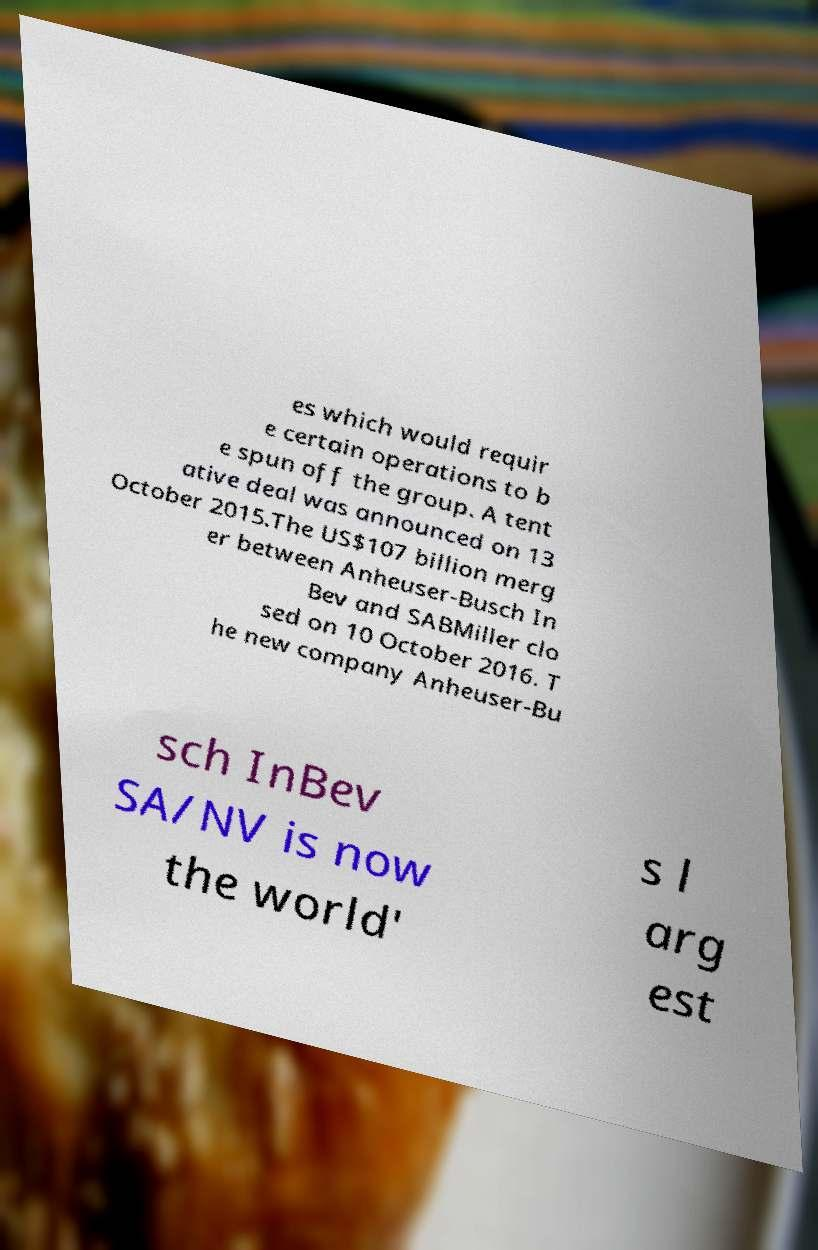For documentation purposes, I need the text within this image transcribed. Could you provide that? es which would requir e certain operations to b e spun off the group. A tent ative deal was announced on 13 October 2015.The US$107 billion merg er between Anheuser-Busch In Bev and SABMiller clo sed on 10 October 2016. T he new company Anheuser-Bu sch InBev SA/NV is now the world' s l arg est 